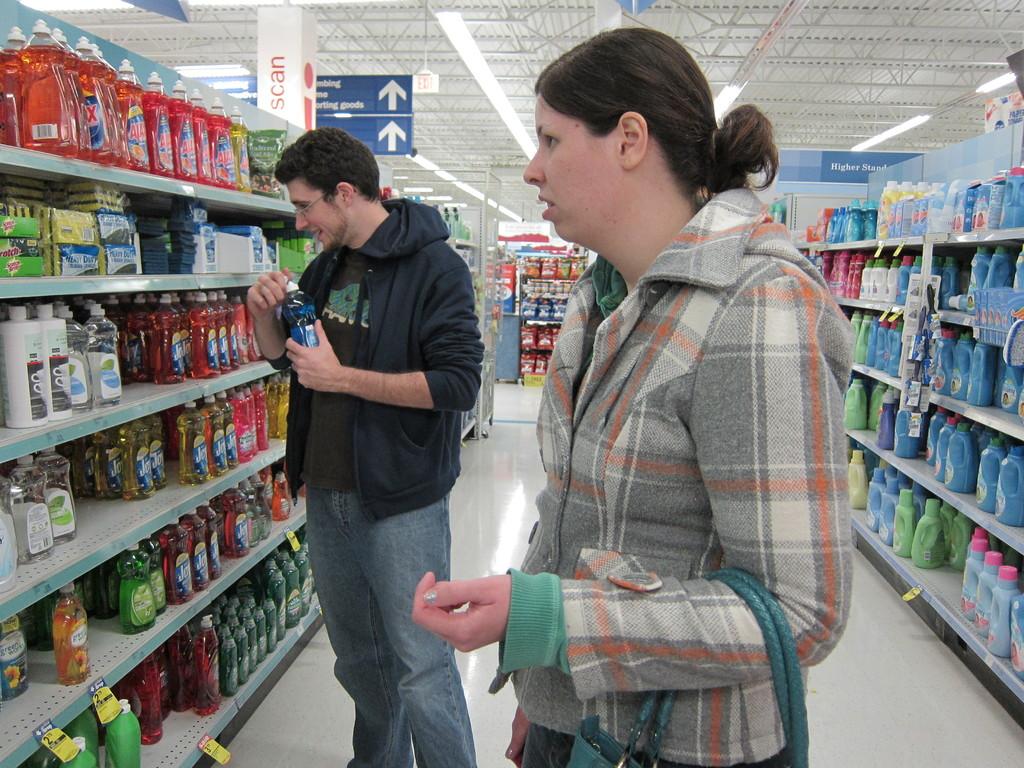What is the name of the orange dish detergent?
Provide a short and direct response. Ajax. 